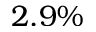<formula> <loc_0><loc_0><loc_500><loc_500>2 . 9 \%</formula> 